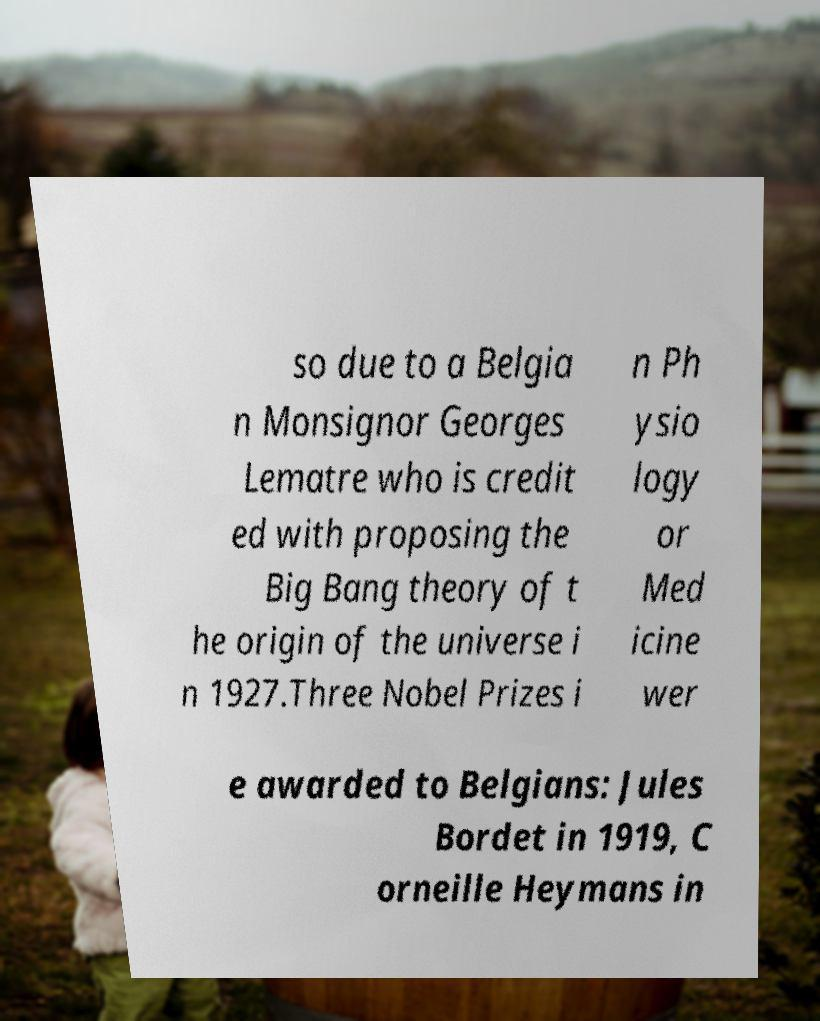What messages or text are displayed in this image? I need them in a readable, typed format. so due to a Belgia n Monsignor Georges Lematre who is credit ed with proposing the Big Bang theory of t he origin of the universe i n 1927.Three Nobel Prizes i n Ph ysio logy or Med icine wer e awarded to Belgians: Jules Bordet in 1919, C orneille Heymans in 